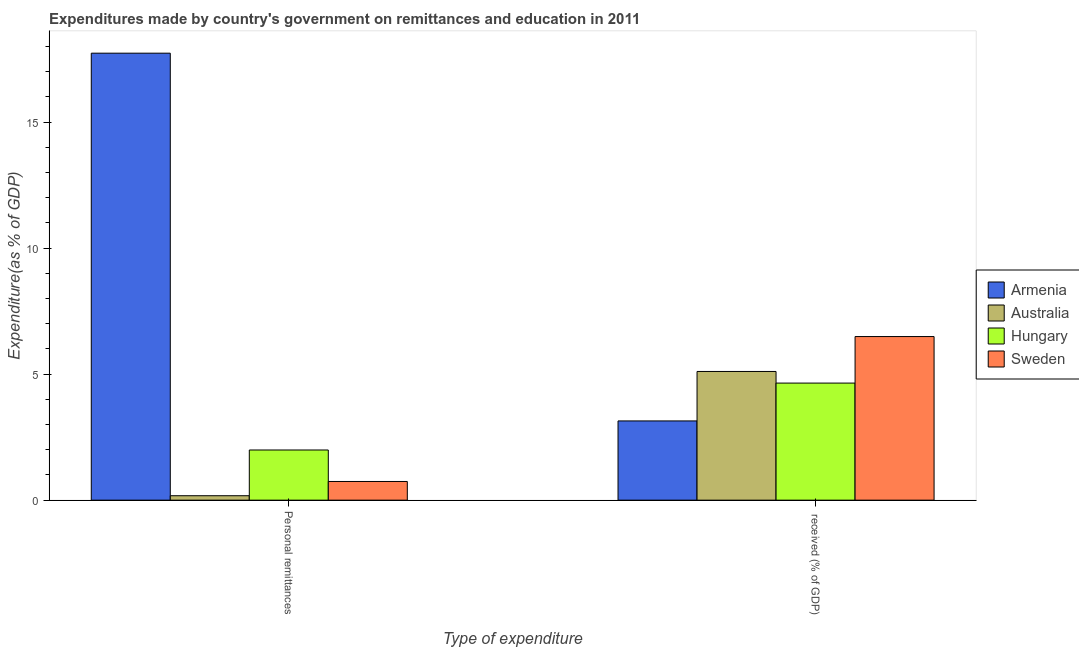How many groups of bars are there?
Your answer should be very brief. 2. Are the number of bars per tick equal to the number of legend labels?
Offer a very short reply. Yes. Are the number of bars on each tick of the X-axis equal?
Keep it short and to the point. Yes. What is the label of the 1st group of bars from the left?
Give a very brief answer. Personal remittances. What is the expenditure in personal remittances in Sweden?
Offer a very short reply. 0.74. Across all countries, what is the maximum expenditure in education?
Provide a short and direct response. 6.49. Across all countries, what is the minimum expenditure in education?
Your answer should be compact. 3.14. In which country was the expenditure in education maximum?
Provide a short and direct response. Sweden. In which country was the expenditure in personal remittances minimum?
Provide a succinct answer. Australia. What is the total expenditure in education in the graph?
Your answer should be very brief. 19.39. What is the difference between the expenditure in personal remittances in Australia and that in Sweden?
Ensure brevity in your answer.  -0.57. What is the difference between the expenditure in education in Hungary and the expenditure in personal remittances in Armenia?
Your response must be concise. -13.09. What is the average expenditure in personal remittances per country?
Ensure brevity in your answer.  5.16. What is the difference between the expenditure in education and expenditure in personal remittances in Sweden?
Keep it short and to the point. 5.75. What is the ratio of the expenditure in personal remittances in Australia to that in Armenia?
Offer a terse response. 0.01. Is the expenditure in education in Hungary less than that in Armenia?
Keep it short and to the point. No. What does the 3rd bar from the left in  received (% of GDP) represents?
Offer a very short reply. Hungary. Are all the bars in the graph horizontal?
Provide a succinct answer. No. Does the graph contain any zero values?
Keep it short and to the point. No. Where does the legend appear in the graph?
Offer a terse response. Center right. How many legend labels are there?
Provide a succinct answer. 4. What is the title of the graph?
Your answer should be very brief. Expenditures made by country's government on remittances and education in 2011. What is the label or title of the X-axis?
Your answer should be compact. Type of expenditure. What is the label or title of the Y-axis?
Make the answer very short. Expenditure(as % of GDP). What is the Expenditure(as % of GDP) of Armenia in Personal remittances?
Your response must be concise. 17.73. What is the Expenditure(as % of GDP) of Australia in Personal remittances?
Make the answer very short. 0.18. What is the Expenditure(as % of GDP) of Hungary in Personal remittances?
Offer a terse response. 1.99. What is the Expenditure(as % of GDP) of Sweden in Personal remittances?
Make the answer very short. 0.74. What is the Expenditure(as % of GDP) in Armenia in  received (% of GDP)?
Your response must be concise. 3.14. What is the Expenditure(as % of GDP) of Australia in  received (% of GDP)?
Provide a short and direct response. 5.11. What is the Expenditure(as % of GDP) of Hungary in  received (% of GDP)?
Your answer should be compact. 4.65. What is the Expenditure(as % of GDP) of Sweden in  received (% of GDP)?
Provide a short and direct response. 6.49. Across all Type of expenditure, what is the maximum Expenditure(as % of GDP) in Armenia?
Give a very brief answer. 17.73. Across all Type of expenditure, what is the maximum Expenditure(as % of GDP) in Australia?
Offer a very short reply. 5.11. Across all Type of expenditure, what is the maximum Expenditure(as % of GDP) in Hungary?
Give a very brief answer. 4.65. Across all Type of expenditure, what is the maximum Expenditure(as % of GDP) of Sweden?
Ensure brevity in your answer.  6.49. Across all Type of expenditure, what is the minimum Expenditure(as % of GDP) of Armenia?
Give a very brief answer. 3.14. Across all Type of expenditure, what is the minimum Expenditure(as % of GDP) of Australia?
Offer a very short reply. 0.18. Across all Type of expenditure, what is the minimum Expenditure(as % of GDP) in Hungary?
Give a very brief answer. 1.99. Across all Type of expenditure, what is the minimum Expenditure(as % of GDP) in Sweden?
Give a very brief answer. 0.74. What is the total Expenditure(as % of GDP) of Armenia in the graph?
Your response must be concise. 20.88. What is the total Expenditure(as % of GDP) of Australia in the graph?
Provide a short and direct response. 5.28. What is the total Expenditure(as % of GDP) in Hungary in the graph?
Make the answer very short. 6.64. What is the total Expenditure(as % of GDP) in Sweden in the graph?
Provide a succinct answer. 7.23. What is the difference between the Expenditure(as % of GDP) in Armenia in Personal remittances and that in  received (% of GDP)?
Your response must be concise. 14.59. What is the difference between the Expenditure(as % of GDP) of Australia in Personal remittances and that in  received (% of GDP)?
Your response must be concise. -4.93. What is the difference between the Expenditure(as % of GDP) of Hungary in Personal remittances and that in  received (% of GDP)?
Ensure brevity in your answer.  -2.65. What is the difference between the Expenditure(as % of GDP) in Sweden in Personal remittances and that in  received (% of GDP)?
Provide a short and direct response. -5.75. What is the difference between the Expenditure(as % of GDP) of Armenia in Personal remittances and the Expenditure(as % of GDP) of Australia in  received (% of GDP)?
Ensure brevity in your answer.  12.63. What is the difference between the Expenditure(as % of GDP) of Armenia in Personal remittances and the Expenditure(as % of GDP) of Hungary in  received (% of GDP)?
Offer a terse response. 13.09. What is the difference between the Expenditure(as % of GDP) in Armenia in Personal remittances and the Expenditure(as % of GDP) in Sweden in  received (% of GDP)?
Your answer should be very brief. 11.24. What is the difference between the Expenditure(as % of GDP) of Australia in Personal remittances and the Expenditure(as % of GDP) of Hungary in  received (% of GDP)?
Give a very brief answer. -4.47. What is the difference between the Expenditure(as % of GDP) in Australia in Personal remittances and the Expenditure(as % of GDP) in Sweden in  received (% of GDP)?
Provide a short and direct response. -6.31. What is the difference between the Expenditure(as % of GDP) of Hungary in Personal remittances and the Expenditure(as % of GDP) of Sweden in  received (% of GDP)?
Offer a terse response. -4.5. What is the average Expenditure(as % of GDP) in Armenia per Type of expenditure?
Keep it short and to the point. 10.44. What is the average Expenditure(as % of GDP) of Australia per Type of expenditure?
Your answer should be very brief. 2.64. What is the average Expenditure(as % of GDP) in Hungary per Type of expenditure?
Offer a terse response. 3.32. What is the average Expenditure(as % of GDP) of Sweden per Type of expenditure?
Provide a succinct answer. 3.62. What is the difference between the Expenditure(as % of GDP) in Armenia and Expenditure(as % of GDP) in Australia in Personal remittances?
Provide a succinct answer. 17.56. What is the difference between the Expenditure(as % of GDP) of Armenia and Expenditure(as % of GDP) of Hungary in Personal remittances?
Give a very brief answer. 15.74. What is the difference between the Expenditure(as % of GDP) of Armenia and Expenditure(as % of GDP) of Sweden in Personal remittances?
Keep it short and to the point. 16.99. What is the difference between the Expenditure(as % of GDP) of Australia and Expenditure(as % of GDP) of Hungary in Personal remittances?
Offer a very short reply. -1.81. What is the difference between the Expenditure(as % of GDP) of Australia and Expenditure(as % of GDP) of Sweden in Personal remittances?
Ensure brevity in your answer.  -0.57. What is the difference between the Expenditure(as % of GDP) of Hungary and Expenditure(as % of GDP) of Sweden in Personal remittances?
Your answer should be compact. 1.25. What is the difference between the Expenditure(as % of GDP) in Armenia and Expenditure(as % of GDP) in Australia in  received (% of GDP)?
Your answer should be compact. -1.96. What is the difference between the Expenditure(as % of GDP) of Armenia and Expenditure(as % of GDP) of Hungary in  received (% of GDP)?
Provide a succinct answer. -1.5. What is the difference between the Expenditure(as % of GDP) in Armenia and Expenditure(as % of GDP) in Sweden in  received (% of GDP)?
Offer a very short reply. -3.35. What is the difference between the Expenditure(as % of GDP) of Australia and Expenditure(as % of GDP) of Hungary in  received (% of GDP)?
Ensure brevity in your answer.  0.46. What is the difference between the Expenditure(as % of GDP) in Australia and Expenditure(as % of GDP) in Sweden in  received (% of GDP)?
Offer a very short reply. -1.39. What is the difference between the Expenditure(as % of GDP) of Hungary and Expenditure(as % of GDP) of Sweden in  received (% of GDP)?
Provide a succinct answer. -1.85. What is the ratio of the Expenditure(as % of GDP) of Armenia in Personal remittances to that in  received (% of GDP)?
Keep it short and to the point. 5.64. What is the ratio of the Expenditure(as % of GDP) in Australia in Personal remittances to that in  received (% of GDP)?
Keep it short and to the point. 0.03. What is the ratio of the Expenditure(as % of GDP) of Hungary in Personal remittances to that in  received (% of GDP)?
Give a very brief answer. 0.43. What is the ratio of the Expenditure(as % of GDP) of Sweden in Personal remittances to that in  received (% of GDP)?
Ensure brevity in your answer.  0.11. What is the difference between the highest and the second highest Expenditure(as % of GDP) of Armenia?
Your answer should be very brief. 14.59. What is the difference between the highest and the second highest Expenditure(as % of GDP) in Australia?
Offer a terse response. 4.93. What is the difference between the highest and the second highest Expenditure(as % of GDP) of Hungary?
Make the answer very short. 2.65. What is the difference between the highest and the second highest Expenditure(as % of GDP) in Sweden?
Provide a short and direct response. 5.75. What is the difference between the highest and the lowest Expenditure(as % of GDP) in Armenia?
Your answer should be very brief. 14.59. What is the difference between the highest and the lowest Expenditure(as % of GDP) of Australia?
Your response must be concise. 4.93. What is the difference between the highest and the lowest Expenditure(as % of GDP) in Hungary?
Provide a short and direct response. 2.65. What is the difference between the highest and the lowest Expenditure(as % of GDP) in Sweden?
Offer a terse response. 5.75. 